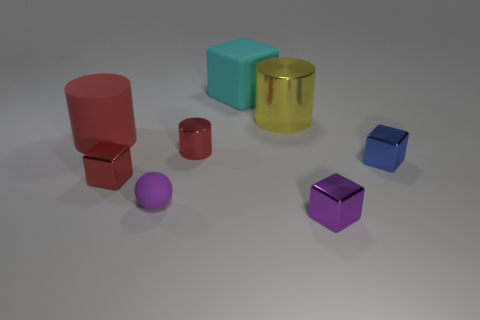How many purple things are rubber cylinders or cubes?
Your answer should be very brief. 1. There is a small block that is on the left side of the cyan thing; what is it made of?
Your response must be concise. Metal. Is the material of the tiny purple object on the right side of the big matte cube the same as the tiny blue object?
Ensure brevity in your answer.  Yes. The large yellow object has what shape?
Your response must be concise. Cylinder. How many matte cylinders are right of the matte object that is to the right of the tiny purple object left of the large cyan cube?
Your response must be concise. 0. How many other objects are there of the same material as the blue block?
Ensure brevity in your answer.  4. There is a red block that is the same size as the matte sphere; what is it made of?
Your response must be concise. Metal. There is a tiny metal thing behind the blue metal cube; is its color the same as the large thing in front of the big yellow metallic cylinder?
Offer a terse response. Yes. Is there a large yellow matte object of the same shape as the big metal object?
Your response must be concise. No. There is a rubber object that is the same size as the purple metal block; what shape is it?
Ensure brevity in your answer.  Sphere. 